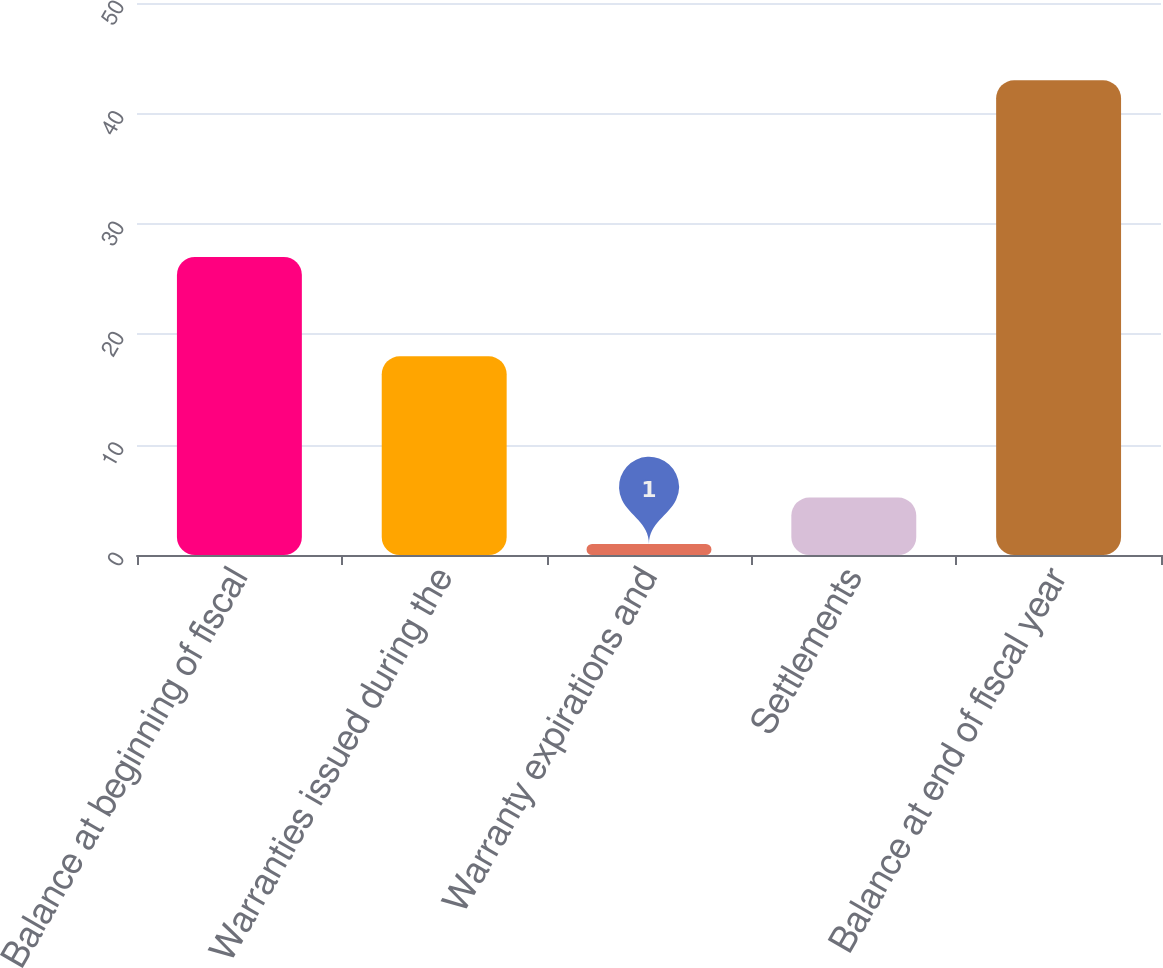Convert chart to OTSL. <chart><loc_0><loc_0><loc_500><loc_500><bar_chart><fcel>Balance at beginning of fiscal<fcel>Warranties issued during the<fcel>Warranty expirations and<fcel>Settlements<fcel>Balance at end of fiscal year<nl><fcel>27<fcel>18<fcel>1<fcel>5.2<fcel>43<nl></chart> 